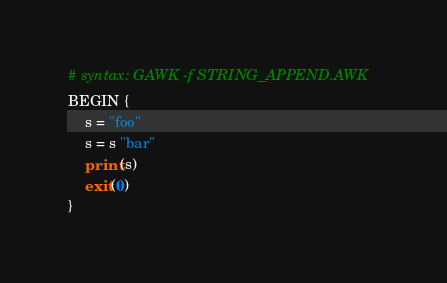Convert code to text. <code><loc_0><loc_0><loc_500><loc_500><_Awk_># syntax: GAWK -f STRING_APPEND.AWK
BEGIN {
    s = "foo"
    s = s "bar"
    print(s)
    exit(0)
}
</code> 